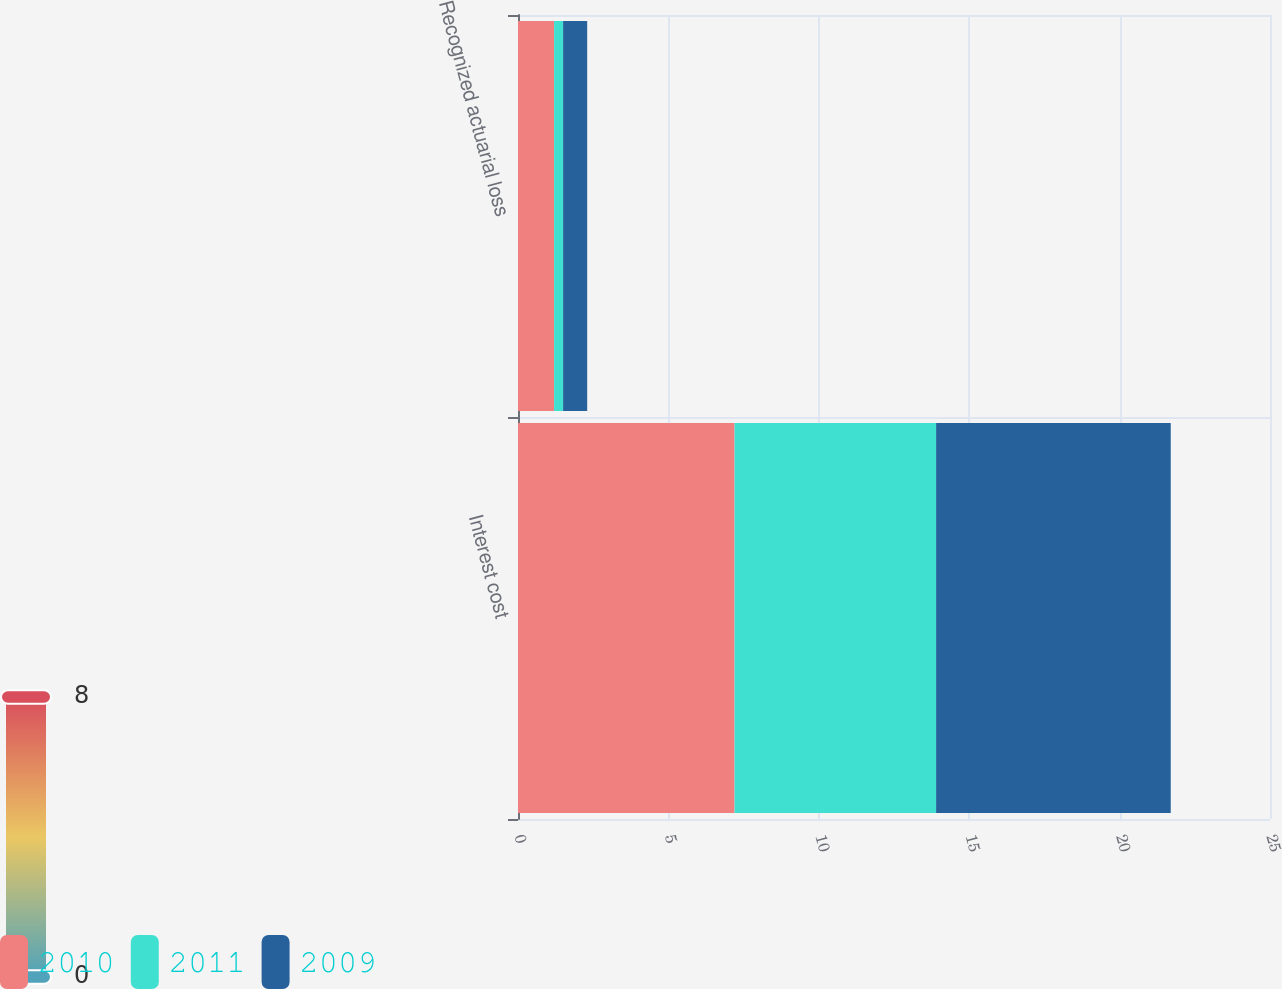Convert chart to OTSL. <chart><loc_0><loc_0><loc_500><loc_500><stacked_bar_chart><ecel><fcel>Interest cost<fcel>Recognized actuarial loss<nl><fcel>2010<fcel>7.2<fcel>1.2<nl><fcel>2011<fcel>6.7<fcel>0.3<nl><fcel>2009<fcel>7.8<fcel>0.8<nl></chart> 